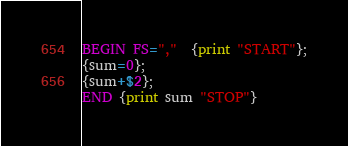<code> <loc_0><loc_0><loc_500><loc_500><_Awk_>BEGIN FS=","  {print "START"};
{sum=0};
{sum+$2};
END {print sum "STOP"}

</code> 